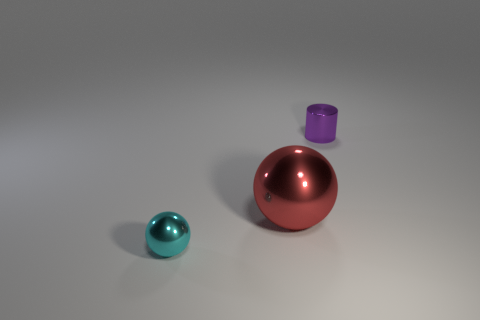Is the number of small blue shiny balls greater than the number of red metallic things?
Provide a short and direct response. No. Is the shape of the big red thing the same as the tiny cyan shiny thing?
Your answer should be compact. Yes. Are there any other things that are the same shape as the purple metal object?
Your response must be concise. No. Are there fewer things that are in front of the small cyan metal ball than objects that are to the right of the red metallic object?
Provide a succinct answer. Yes. The purple thing on the right side of the big metallic thing has what shape?
Your answer should be compact. Cylinder. How many other objects are the same material as the tiny sphere?
Give a very brief answer. 2. Do the large shiny thing and the metallic object that is to the left of the red metal object have the same shape?
Offer a very short reply. Yes. There is a small thing that is the same material as the small cylinder; what shape is it?
Offer a very short reply. Sphere. Is the number of tiny things in front of the purple metal cylinder greater than the number of small cyan metallic things behind the big ball?
Make the answer very short. Yes. What number of things are either spheres or large metal spheres?
Give a very brief answer. 2. 